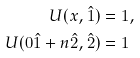Convert formula to latex. <formula><loc_0><loc_0><loc_500><loc_500>U ( x , \hat { 1 } ) & = 1 , \\ U ( 0 \hat { 1 } + n \hat { 2 } , \hat { 2 } ) & = 1</formula> 